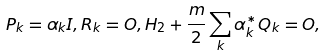<formula> <loc_0><loc_0><loc_500><loc_500>P _ { k } = \alpha _ { k } I , R _ { k } = O , H _ { 2 } + \frac { \i m } { 2 } \sum _ { k } \alpha _ { k } ^ { * } Q _ { k } = O ,</formula> 